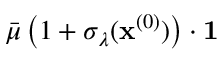<formula> <loc_0><loc_0><loc_500><loc_500>\bar { \mu } \, \left ( 1 + \sigma _ { \lambda } ( x ^ { ( 0 ) } ) \right ) \cdot 1</formula> 